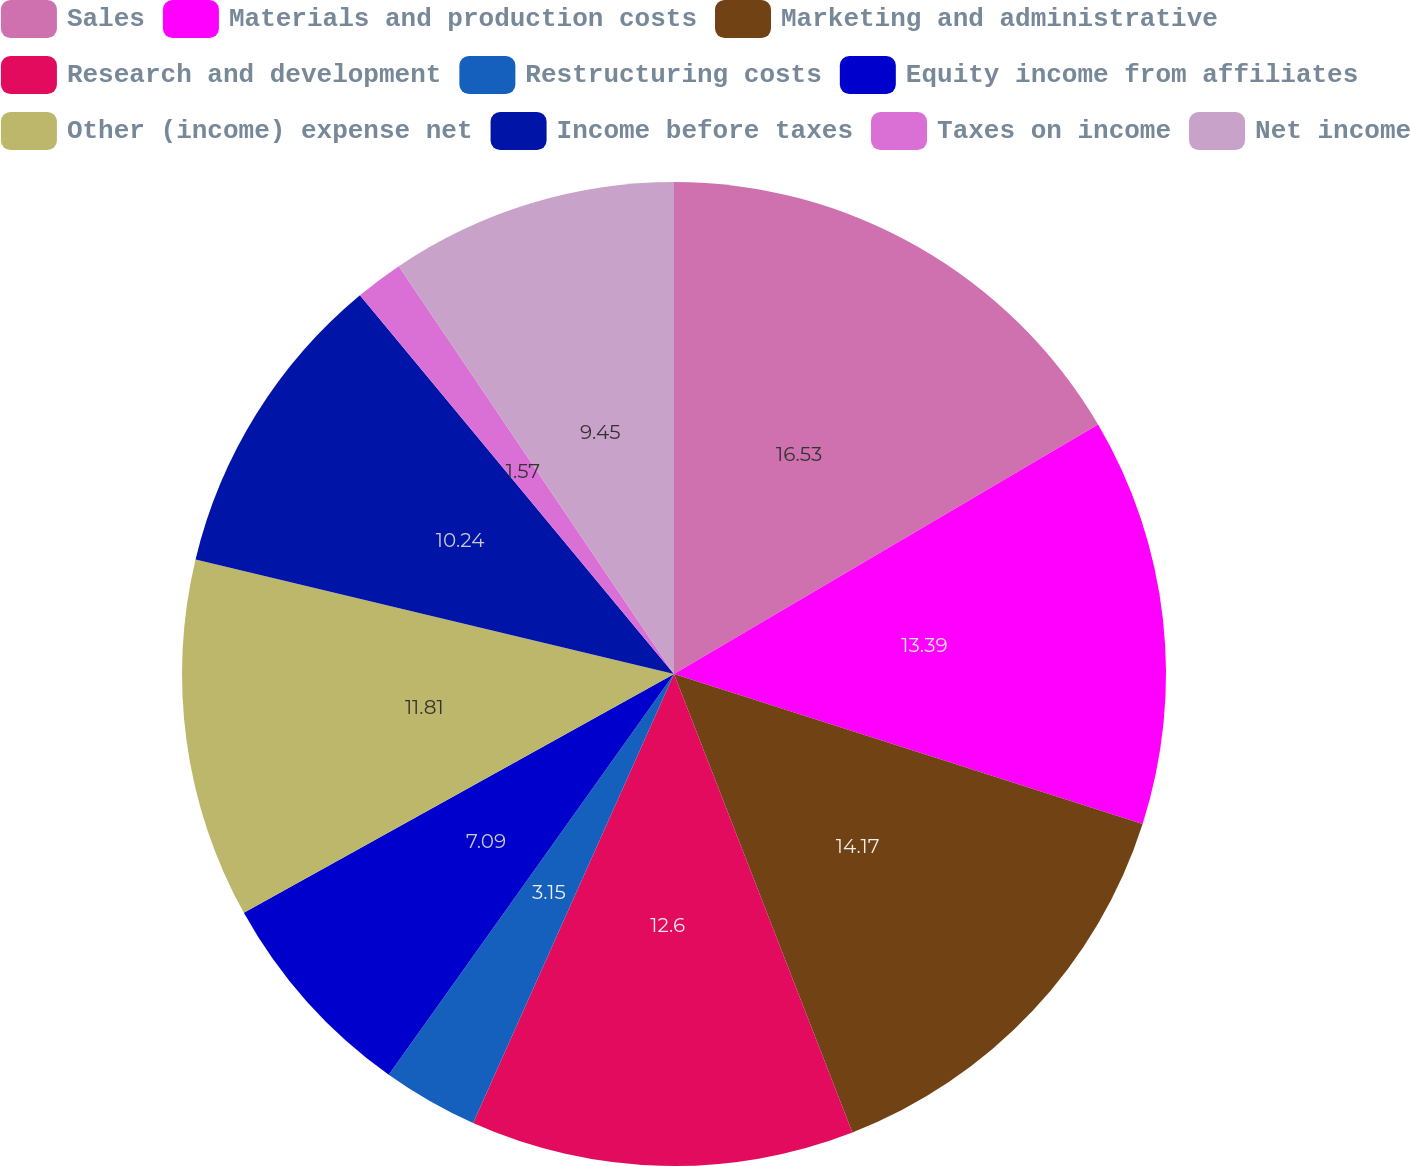Convert chart to OTSL. <chart><loc_0><loc_0><loc_500><loc_500><pie_chart><fcel>Sales<fcel>Materials and production costs<fcel>Marketing and administrative<fcel>Research and development<fcel>Restructuring costs<fcel>Equity income from affiliates<fcel>Other (income) expense net<fcel>Income before taxes<fcel>Taxes on income<fcel>Net income<nl><fcel>16.54%<fcel>13.39%<fcel>14.17%<fcel>12.6%<fcel>3.15%<fcel>7.09%<fcel>11.81%<fcel>10.24%<fcel>1.57%<fcel>9.45%<nl></chart> 